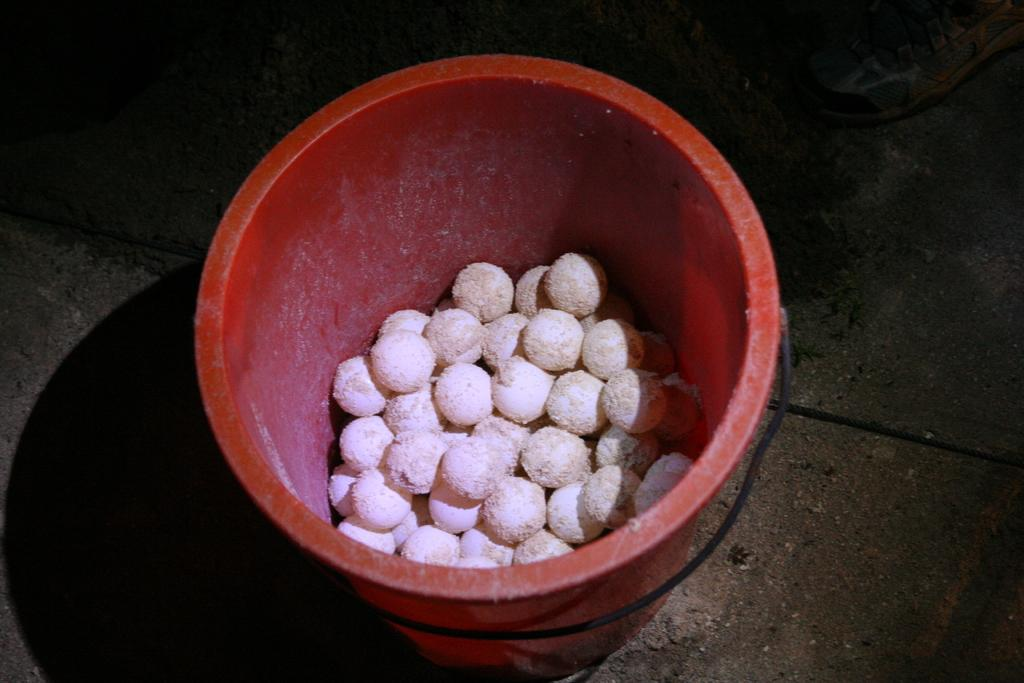What type of food items can be seen in the image? There are round white color food items in the image. Where are the food items located? The food items are in a red color dustbin. Can you describe the location of the dustbin? The dustbin is on the road. What type of bubble can be seen floating near the food items in the image? There is no bubble present in the image. What color is the flag that is waving near the dustbin in the image? There is no flag present in the image. 